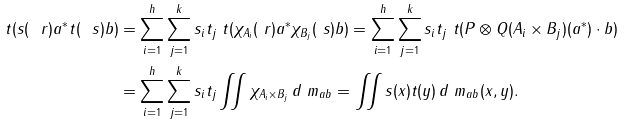Convert formula to latex. <formula><loc_0><loc_0><loc_500><loc_500>\ t ( s ( \ r ) a ^ { * } t ( \ s ) b ) & = \sum _ { i = 1 } ^ { h } \sum _ { j = 1 } ^ { k } s _ { i } t _ { j } \ t ( \chi _ { A _ { i } } ( \ r ) a ^ { * } \chi _ { B _ { j } } ( \ s ) b ) = \sum _ { i = 1 } ^ { h } \sum _ { j = 1 } ^ { k } s _ { i } t _ { j } \ t ( P \otimes Q ( A _ { i } \times B _ { j } ) ( a ^ { * } ) \cdot b ) \\ & = \sum _ { i = 1 } ^ { h } \sum _ { j = 1 } ^ { k } s _ { i } t _ { j } \iint \chi _ { A _ { i } \times B _ { j } } \, d \ m _ { a b } = \iint s ( x ) t ( y ) \, d \ m _ { a b } ( x , y ) .</formula> 